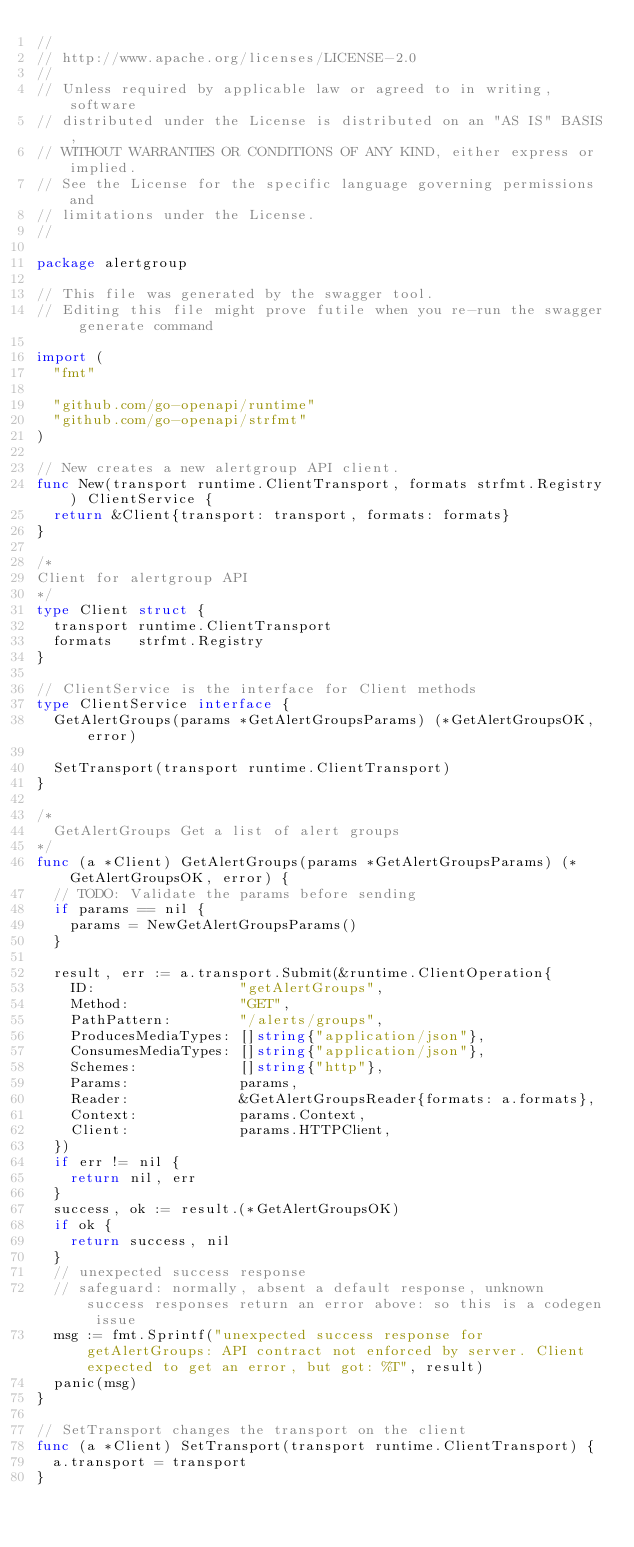Convert code to text. <code><loc_0><loc_0><loc_500><loc_500><_Go_>//
// http://www.apache.org/licenses/LICENSE-2.0
//
// Unless required by applicable law or agreed to in writing, software
// distributed under the License is distributed on an "AS IS" BASIS,
// WITHOUT WARRANTIES OR CONDITIONS OF ANY KIND, either express or implied.
// See the License for the specific language governing permissions and
// limitations under the License.
//

package alertgroup

// This file was generated by the swagger tool.
// Editing this file might prove futile when you re-run the swagger generate command

import (
	"fmt"

	"github.com/go-openapi/runtime"
	"github.com/go-openapi/strfmt"
)

// New creates a new alertgroup API client.
func New(transport runtime.ClientTransport, formats strfmt.Registry) ClientService {
	return &Client{transport: transport, formats: formats}
}

/*
Client for alertgroup API
*/
type Client struct {
	transport runtime.ClientTransport
	formats   strfmt.Registry
}

// ClientService is the interface for Client methods
type ClientService interface {
	GetAlertGroups(params *GetAlertGroupsParams) (*GetAlertGroupsOK, error)

	SetTransport(transport runtime.ClientTransport)
}

/*
  GetAlertGroups Get a list of alert groups
*/
func (a *Client) GetAlertGroups(params *GetAlertGroupsParams) (*GetAlertGroupsOK, error) {
	// TODO: Validate the params before sending
	if params == nil {
		params = NewGetAlertGroupsParams()
	}

	result, err := a.transport.Submit(&runtime.ClientOperation{
		ID:                 "getAlertGroups",
		Method:             "GET",
		PathPattern:        "/alerts/groups",
		ProducesMediaTypes: []string{"application/json"},
		ConsumesMediaTypes: []string{"application/json"},
		Schemes:            []string{"http"},
		Params:             params,
		Reader:             &GetAlertGroupsReader{formats: a.formats},
		Context:            params.Context,
		Client:             params.HTTPClient,
	})
	if err != nil {
		return nil, err
	}
	success, ok := result.(*GetAlertGroupsOK)
	if ok {
		return success, nil
	}
	// unexpected success response
	// safeguard: normally, absent a default response, unknown success responses return an error above: so this is a codegen issue
	msg := fmt.Sprintf("unexpected success response for getAlertGroups: API contract not enforced by server. Client expected to get an error, but got: %T", result)
	panic(msg)
}

// SetTransport changes the transport on the client
func (a *Client) SetTransport(transport runtime.ClientTransport) {
	a.transport = transport
}
</code> 